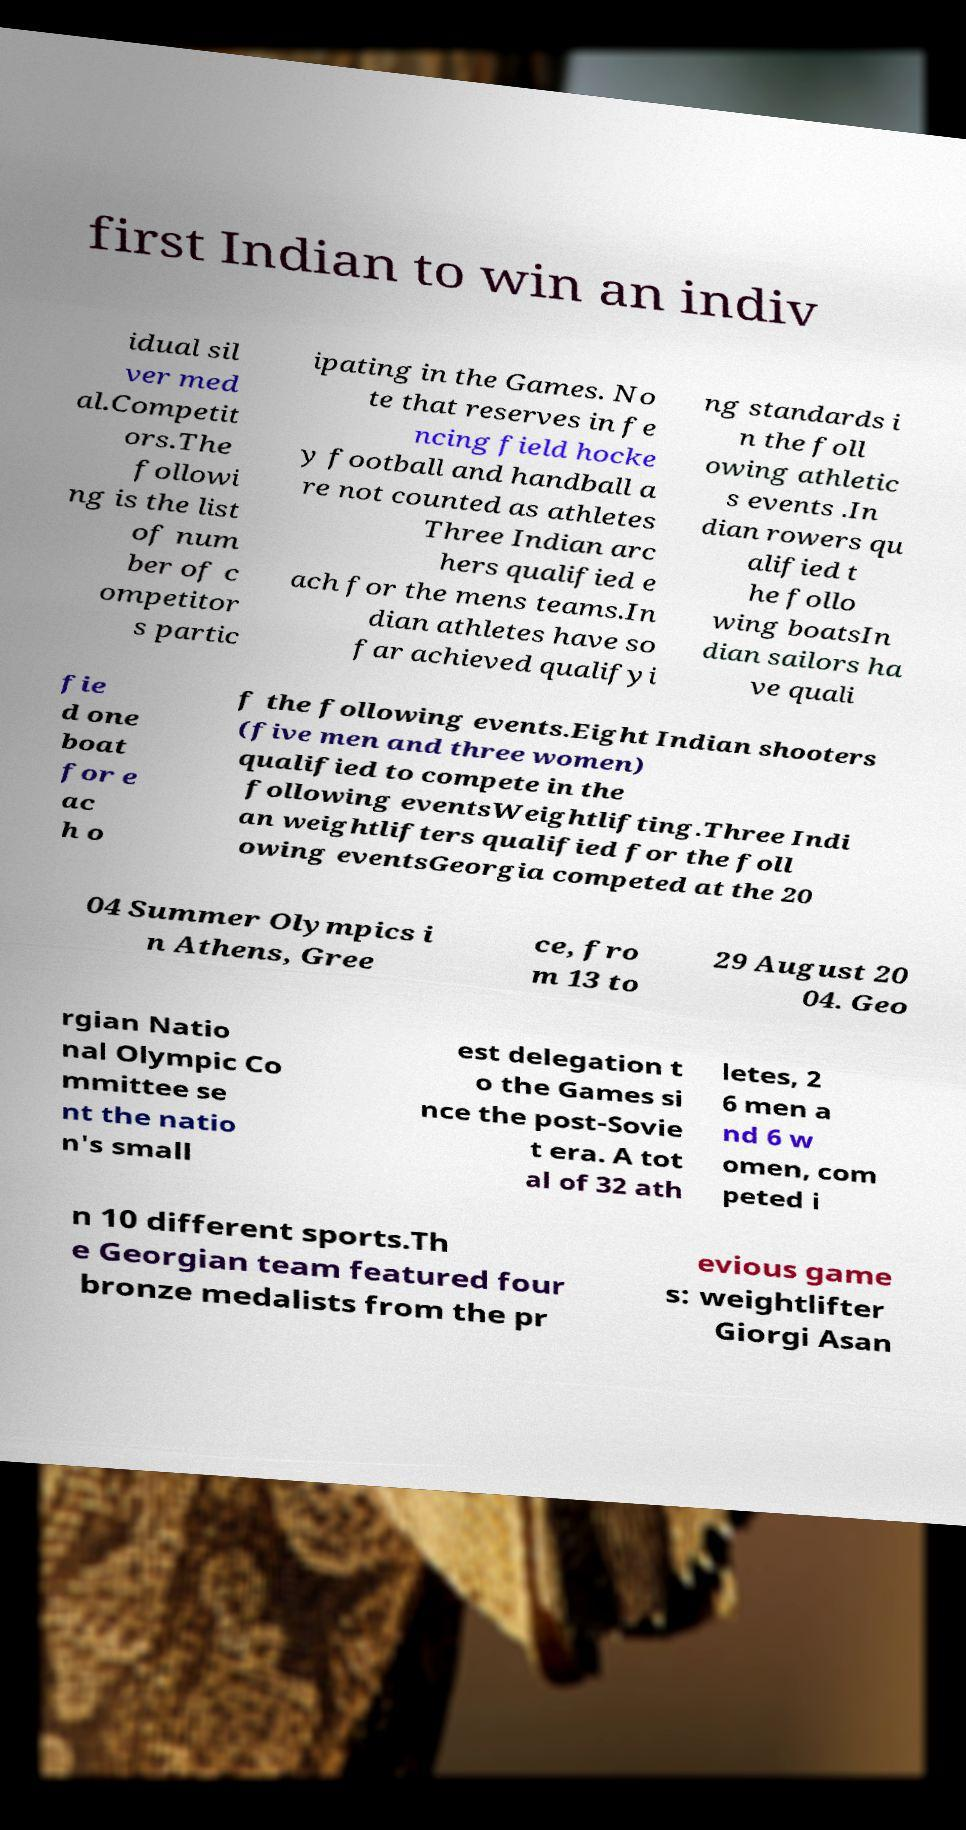Please identify and transcribe the text found in this image. first Indian to win an indiv idual sil ver med al.Competit ors.The followi ng is the list of num ber of c ompetitor s partic ipating in the Games. No te that reserves in fe ncing field hocke y football and handball a re not counted as athletes Three Indian arc hers qualified e ach for the mens teams.In dian athletes have so far achieved qualifyi ng standards i n the foll owing athletic s events .In dian rowers qu alified t he follo wing boatsIn dian sailors ha ve quali fie d one boat for e ac h o f the following events.Eight Indian shooters (five men and three women) qualified to compete in the following eventsWeightlifting.Three Indi an weightlifters qualified for the foll owing eventsGeorgia competed at the 20 04 Summer Olympics i n Athens, Gree ce, fro m 13 to 29 August 20 04. Geo rgian Natio nal Olympic Co mmittee se nt the natio n's small est delegation t o the Games si nce the post-Sovie t era. A tot al of 32 ath letes, 2 6 men a nd 6 w omen, com peted i n 10 different sports.Th e Georgian team featured four bronze medalists from the pr evious game s: weightlifter Giorgi Asan 